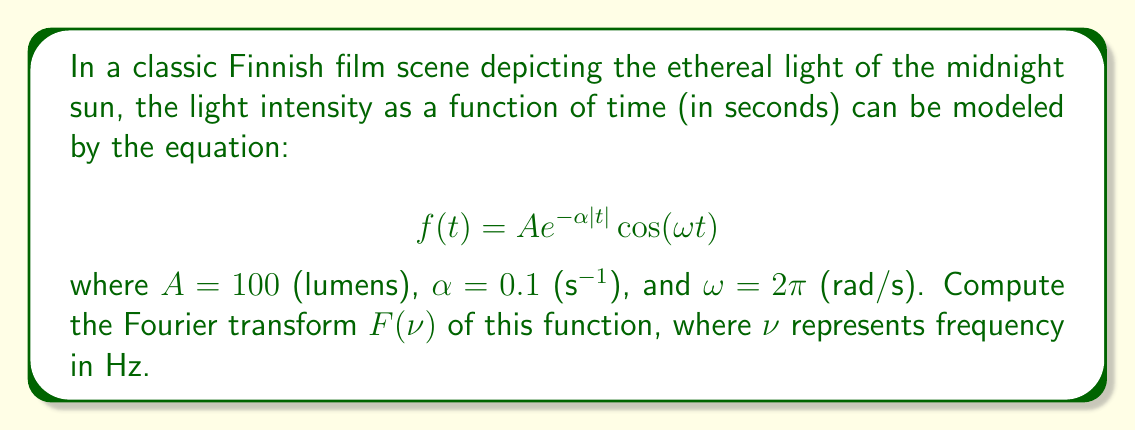Provide a solution to this math problem. To solve this problem, we'll follow these steps:

1) Recall the Fourier transform formula:
   $$F(\nu) = \int_{-\infty}^{\infty} f(t) e^{-i2\pi\nu t} dt$$

2) Substitute our function $f(t) = A e^{-\alpha|t|} \cos(\omega t)$ into the formula:
   $$F(\nu) = A \int_{-\infty}^{\infty} e^{-\alpha|t|} \cos(\omega t) e^{-i2\pi\nu t} dt$$

3) Use Euler's formula to express $\cos(\omega t)$:
   $$\cos(\omega t) = \frac{e^{i\omega t} + e^{-i\omega t}}{2}$$

4) Substitute this into our integral:
   $$F(\nu) = \frac{A}{2} \int_{-\infty}^{\infty} e^{-\alpha|t|} (e^{i\omega t} + e^{-i\omega t}) e^{-i2\pi\nu t} dt$$

5) Distribute the $e^{-i2\pi\nu t}$ term:
   $$F(\nu) = \frac{A}{2} \int_{-\infty}^{\infty} e^{-\alpha|t|} (e^{i(\omega-2\pi\nu) t} + e^{-i(\omega+2\pi\nu) t}) dt$$

6) Split the integral into two parts:
   $$F(\nu) = \frac{A}{2} \left(\int_{-\infty}^{\infty} e^{-\alpha|t|} e^{i(\omega-2\pi\nu) t} dt + \int_{-\infty}^{\infty} e^{-\alpha|t|} e^{-i(\omega+2\pi\nu) t} dt\right)$$

7) Each of these integrals is of the form $\int_{-\infty}^{\infty} e^{-\alpha|t|} e^{i\beta t} dt$, which has a known solution:
   $$\int_{-\infty}^{\infty} e^{-\alpha|t|} e^{i\beta t} dt = \frac{2\alpha}{\alpha^2 + \beta^2}$$

8) Apply this to our integrals:
   $$F(\nu) = \frac{A}{2} \left(\frac{2\alpha}{\alpha^2 + (\omega-2\pi\nu)^2} + \frac{2\alpha}{\alpha^2 + (\omega+2\pi\nu)^2}\right)$$

9) Simplify:
   $$F(\nu) = A\alpha \left(\frac{1}{\alpha^2 + (\omega-2\pi\nu)^2} + \frac{1}{\alpha^2 + (\omega+2\pi\nu)^2}\right)$$

10) Substitute the given values: $A = 100$, $\alpha = 0.1$, $\omega = 2\pi$:
    $$F(\nu) = 10 \left(\frac{1}{0.01 + (2\pi-2\pi\nu)^2} + \frac{1}{0.01 + (2\pi+2\pi\nu)^2}\right)$$

This is the final form of the Fourier transform.
Answer: $$F(\nu) = 10 \left(\frac{1}{0.01 + (2\pi-2\pi\nu)^2} + \frac{1}{0.01 + (2\pi+2\pi\nu)^2}\right)$$ 